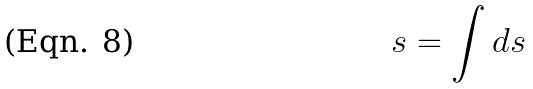Convert formula to latex. <formula><loc_0><loc_0><loc_500><loc_500>s = \int d s</formula> 